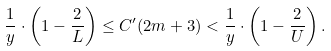<formula> <loc_0><loc_0><loc_500><loc_500>\frac { 1 } { y } \cdot \left ( 1 - \frac { 2 } { L } \right ) \leq C ^ { \prime } ( 2 m + 3 ) < \frac { 1 } { y } \cdot \left ( 1 - \frac { 2 } { U } \right ) .</formula> 